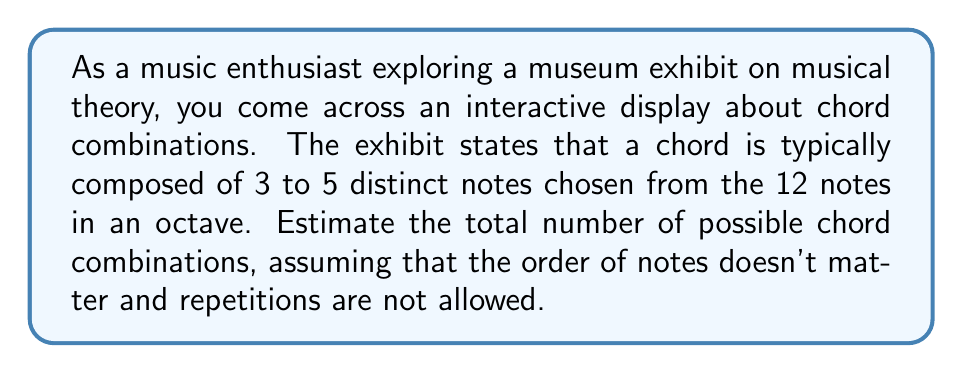Give your solution to this math problem. To solve this problem, we need to use the combination formula for each possible chord size (3, 4, and 5 notes) and then sum the results.

1. For 3-note chords:
   We need to choose 3 notes from 12, which is represented by $\binom{12}{3}$.
   $$\binom{12}{3} = \frac{12!}{3!(12-3)!} = \frac{12!}{3!9!} = 220$$

2. For 4-note chords:
   We choose 4 notes from 12, represented by $\binom{12}{4}$.
   $$\binom{12}{4} = \frac{12!}{4!(12-4)!} = \frac{12!}{4!8!} = 495$$

3. For 5-note chords:
   We choose 5 notes from 12, represented by $\binom{12}{5}$.
   $$\binom{12}{5} = \frac{12!}{5!(12-5)!} = \frac{12!}{5!7!} = 792$$

4. To get the total number of possible chord combinations, we sum these results:
   $$\text{Total combinations} = \binom{12}{3} + \binom{12}{4} + \binom{12}{5}$$
   $$= 220 + 495 + 792 = 1,507$$

Therefore, the total number of possible chord combinations is 1,507.
Answer: 1,507 possible chord combinations 